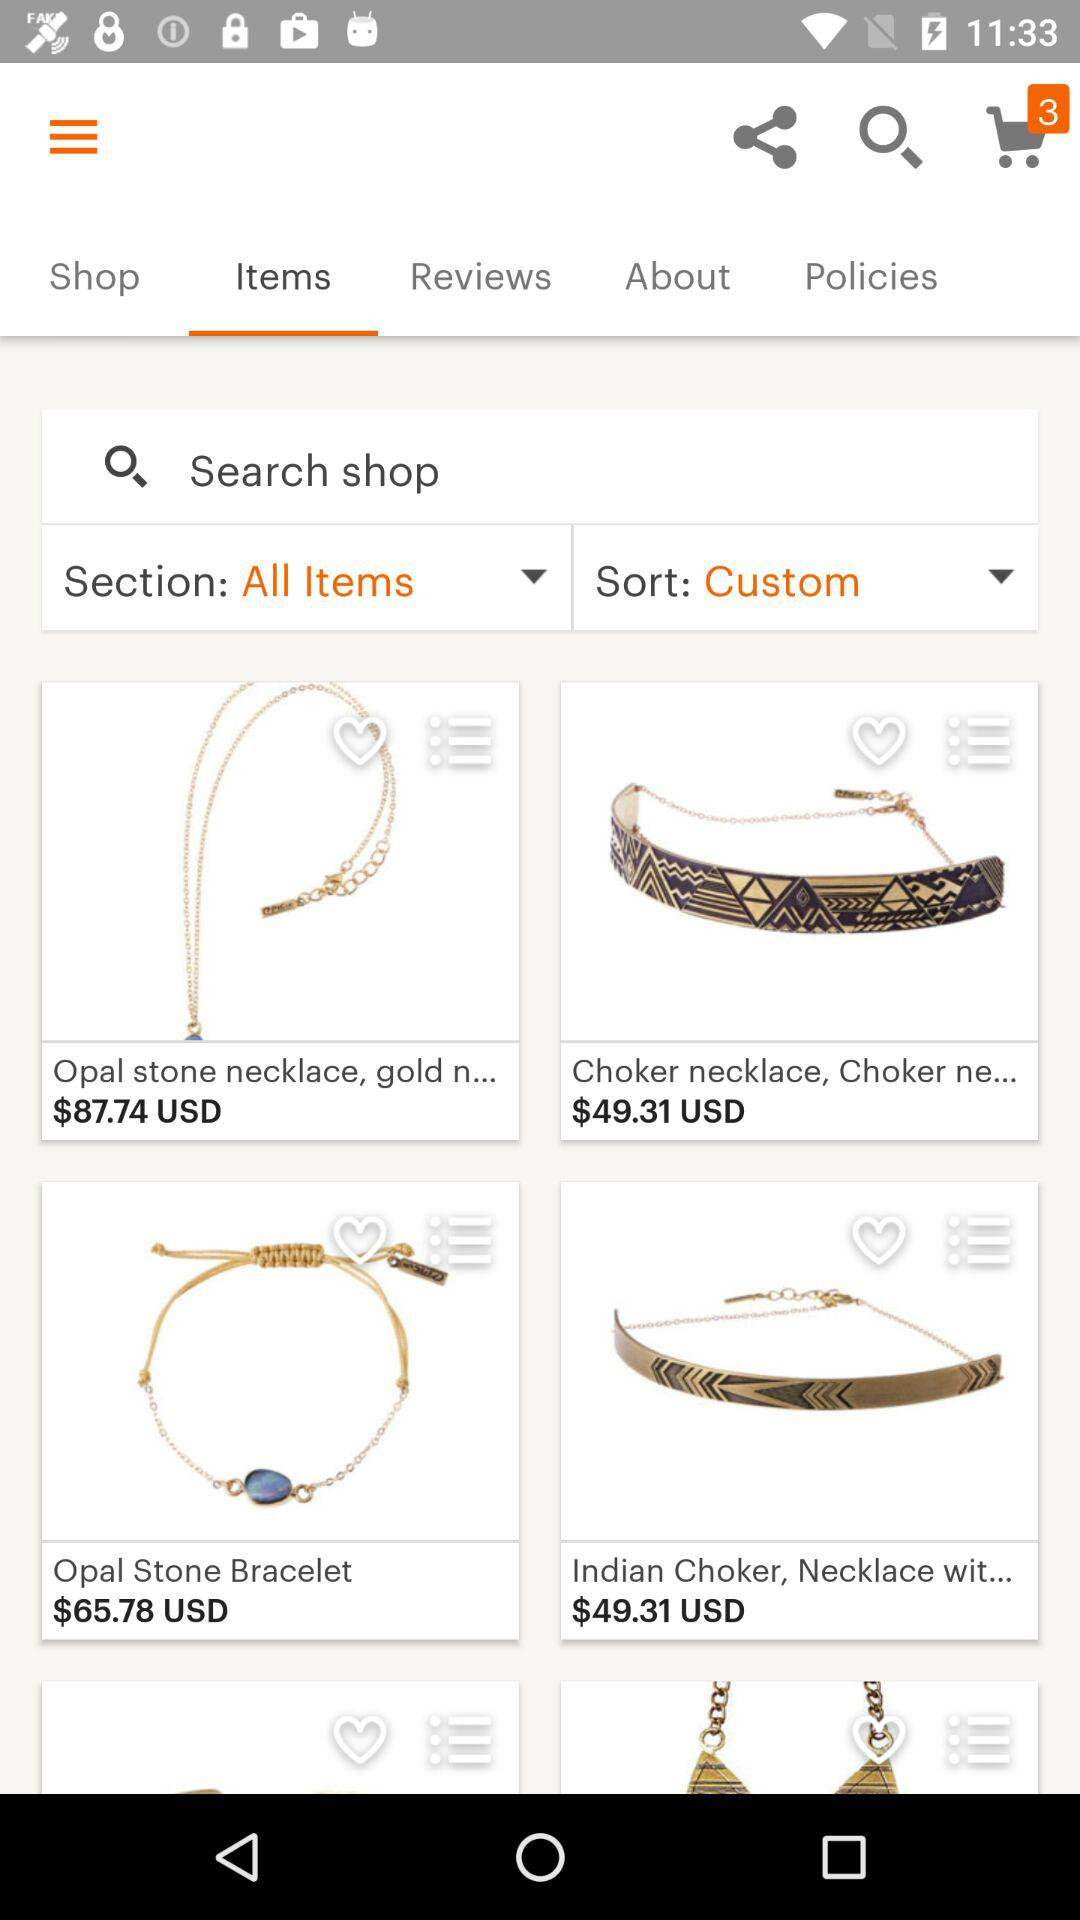Which option is selected in the sort? The selected option is "Custom". 